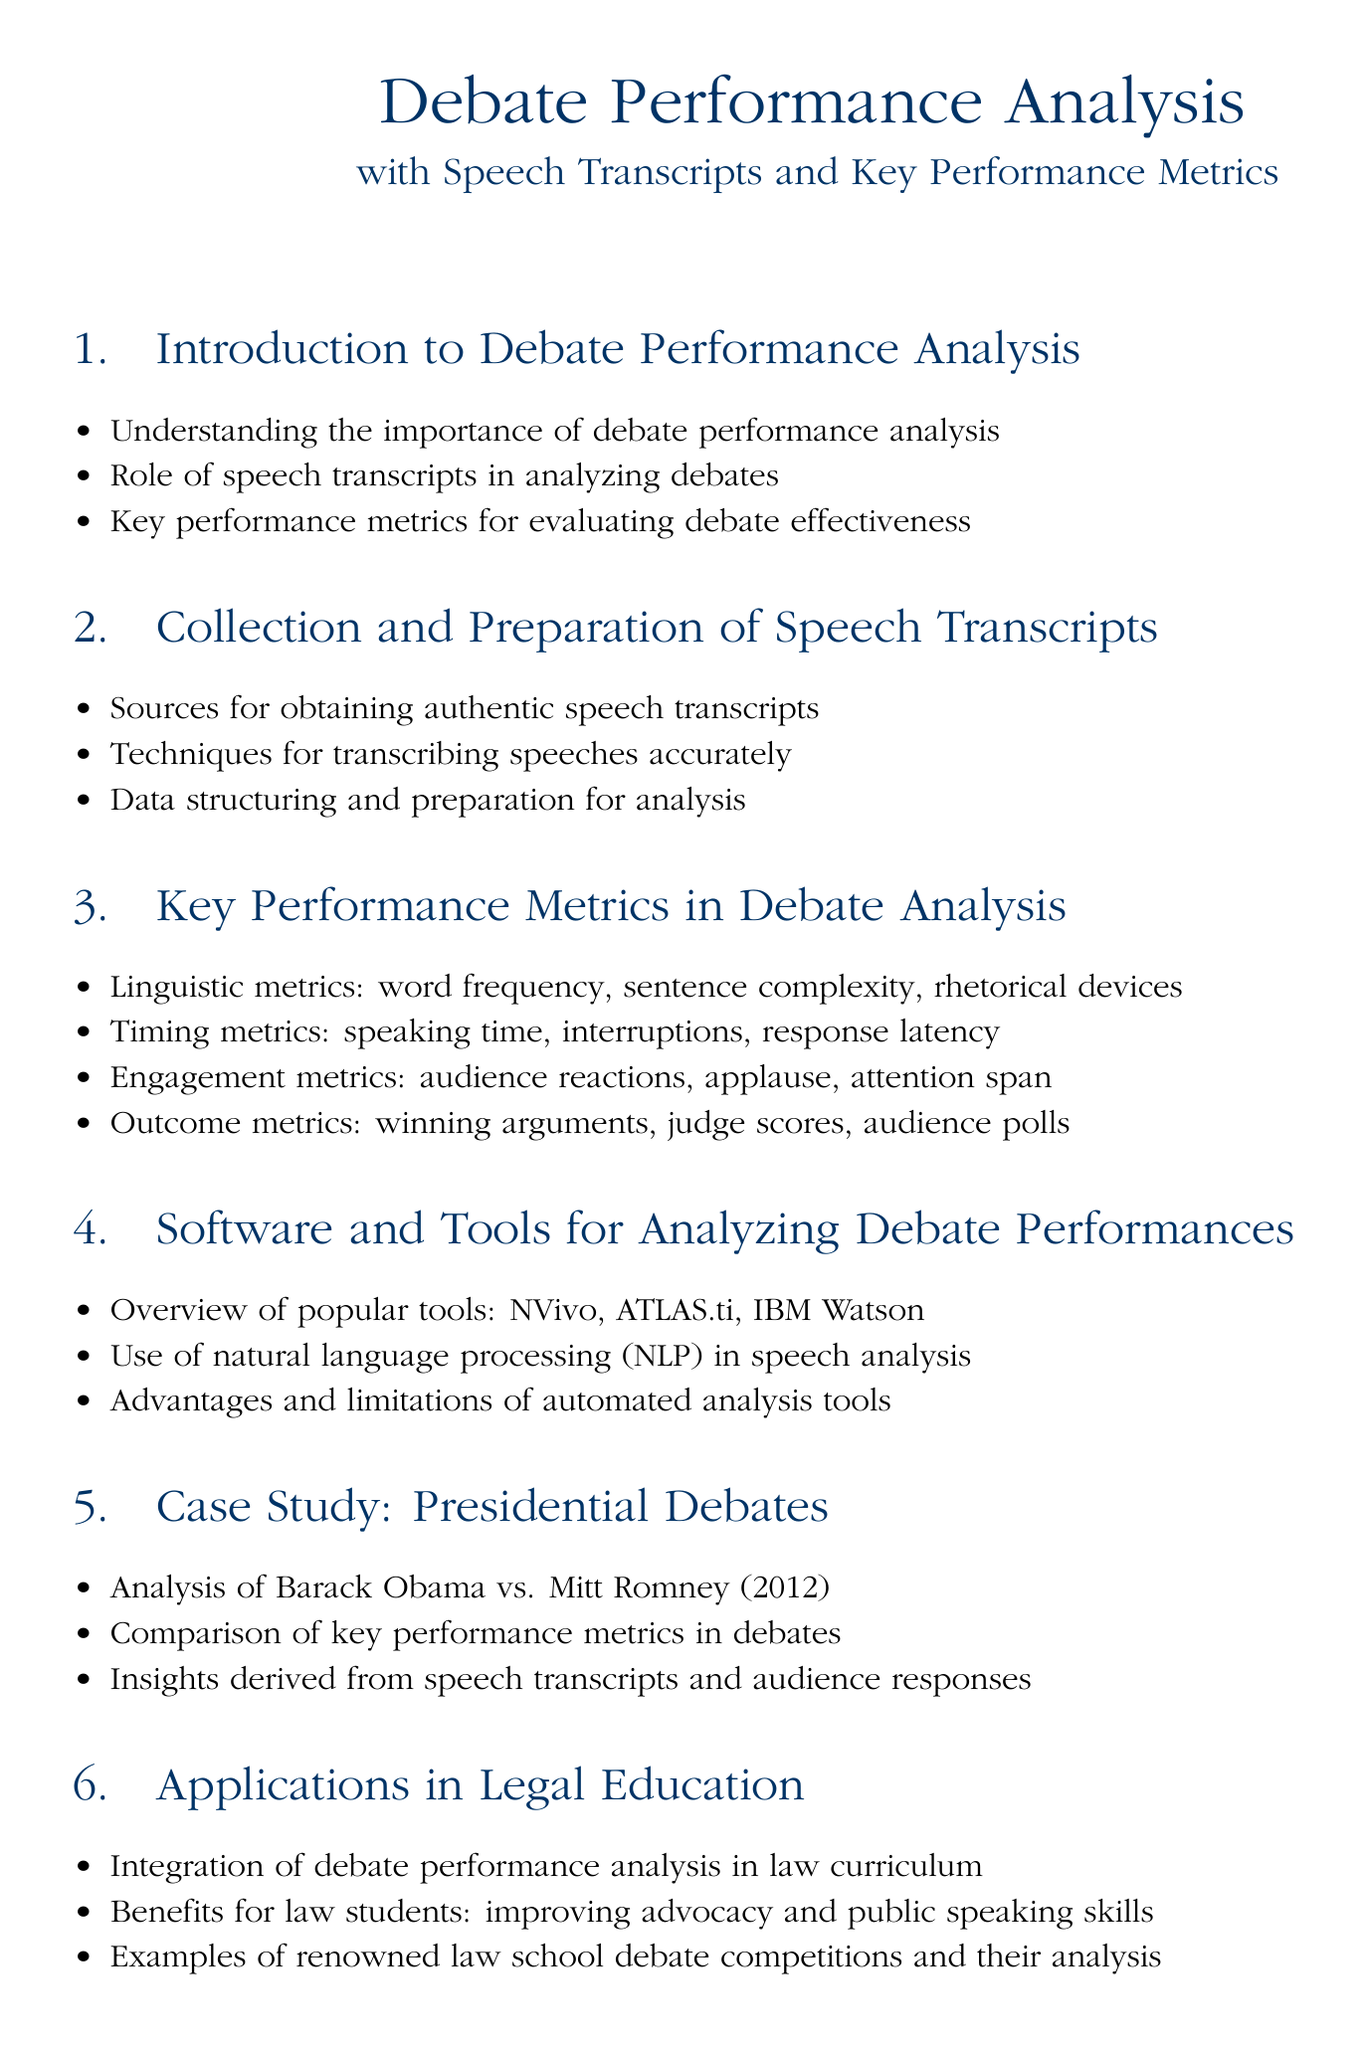What is the title of the document? The title is usually prominently displayed at the beginning of the document, which is "Debate Performance Analysis".
Answer: Debate Performance Analysis What is emphasized in the introduction? The introduction focuses on the importance of debate performance analysis and the role of speech transcripts.
Answer: Importance of debate performance analysis What are the timing metrics mentioned? The document lists various timing metrics in the debate analysis section, including speaking time and response latency.
Answer: Speaking time, interruptions, response latency Which software tool is mentioned for analyzing debate performances? The document provides an overview of popular tools, including NVivo, ATLAS.ti, and IBM Watson.
Answer: NVivo What debate is analyzed in the case study section? The case study section includes specific debates that have been analyzed, specifically mentioning the Obama vs. Romney debate.
Answer: Barack Obama vs. Mitt Romney (2012) What is one benefit of debate performance analysis for law students? The document states the benefit for law students is improving their advocacy and public speaking skills.
Answer: Improving advocacy and public speaking skills What color is used for the main title text? The color specified for the main title text in the document is law blue.
Answer: Law blue 